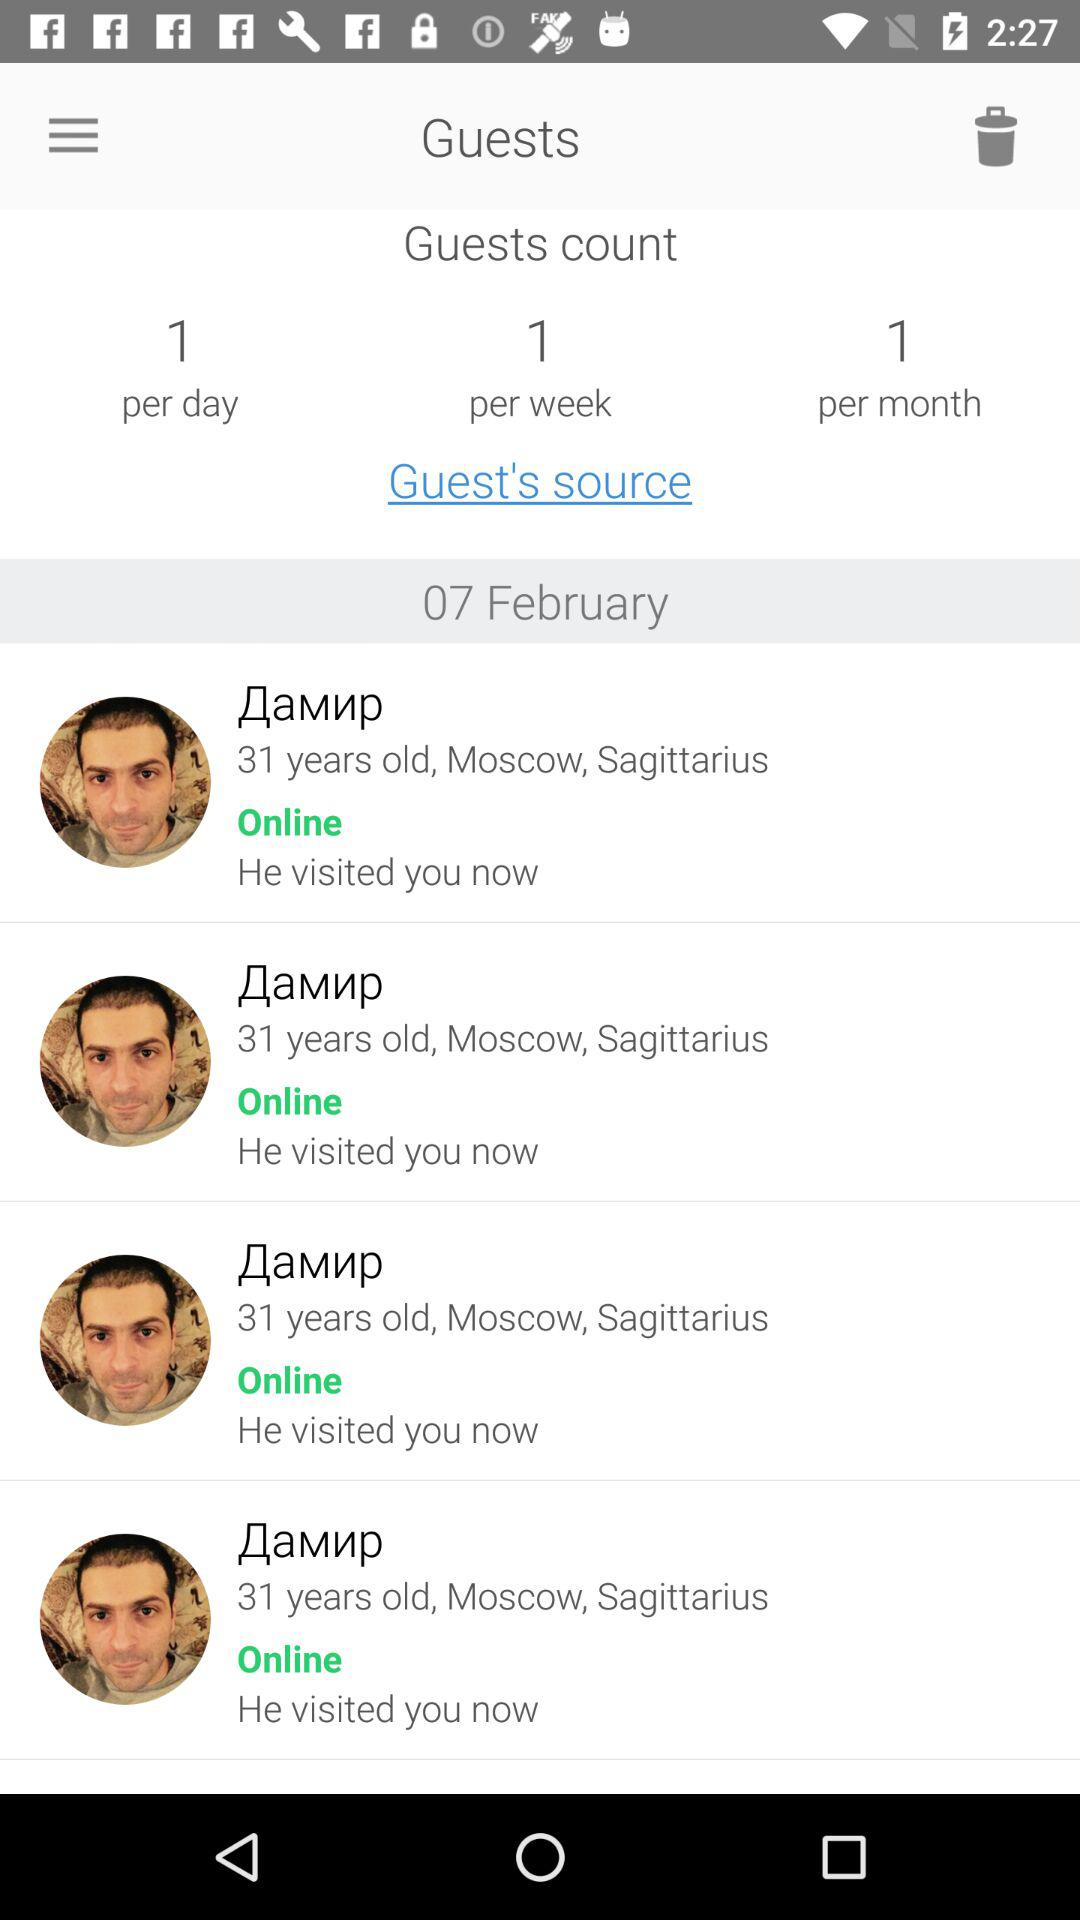What is the guest count per week? The guest count per week is 1. 